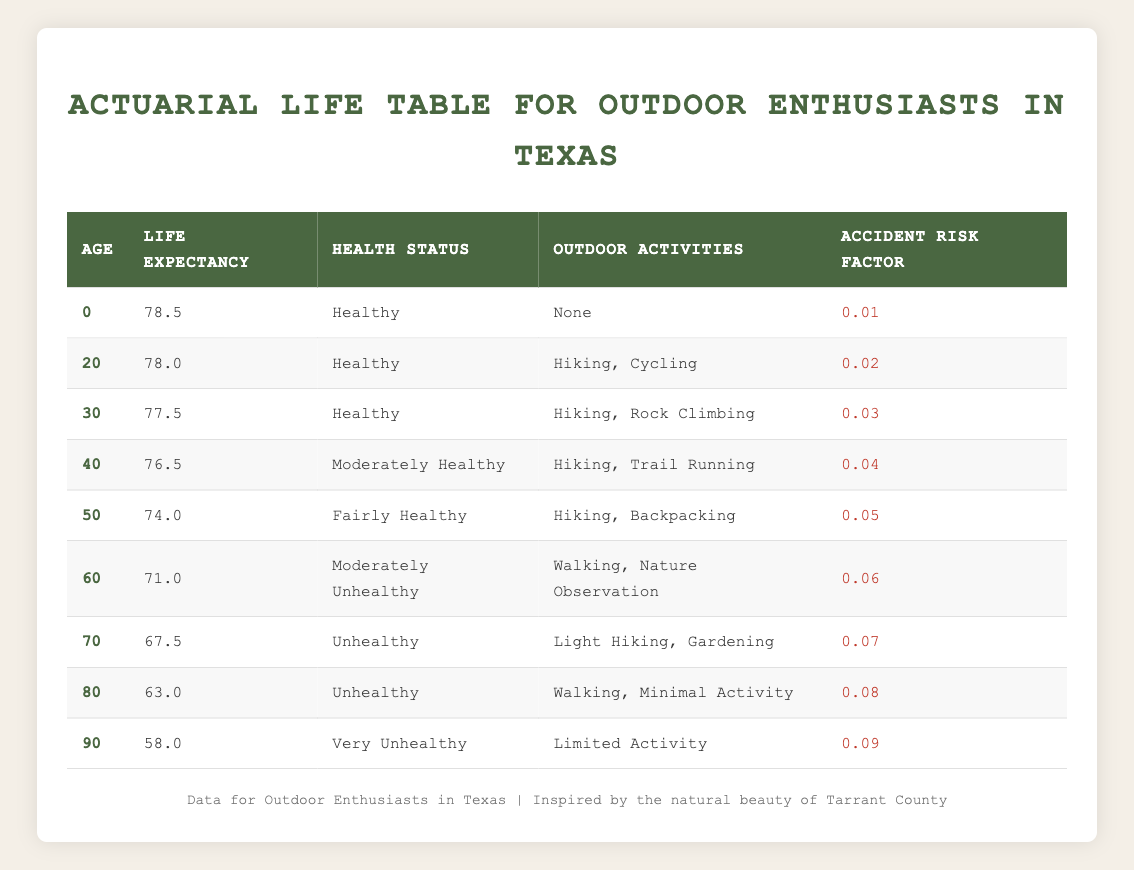What is the life expectancy of outdoor enthusiasts at age 50? From the table, the life expectancy at age 50 is 74.0. This value is directly retrieved from the row corresponding to age 50.
Answer: 74.0 What is the health status of outdoor enthusiasts who are 70 years old? Referring to the table, the health status for individuals at age 70 is listed as "Unhealthy." This is a direct retrieval of the relevant data point.
Answer: Unhealthy At what age does the life expectancy drop below 70 years? By inspecting the table, we see that life expectancy drops below 70 years at age 60 (71.0) and continues to decrease thereafter. Thus, the age at which life expectancy first drops below 70 is 70.
Answer: 70 What is the average life expectancy of outdoor enthusiasts aged 60 and older? To find the average, we take the life expectations at ages 60 (71.0), 70 (67.5), 80 (63.0), and 90 (58.0). Adding these gives 71.0 + 67.5 + 63.0 + 58.0 = 259.0. There are 4 data points, so the average is 259.0 / 4 = 64.75.
Answer: 64.75 Is the accident risk factor higher for those aged 40 than for those aged 30? From the table, the accident risk factor for age 40 is 0.04 while for age 30 it is 0.03. Since 0.04 is greater than 0.03, we conclude it's true that the risk is higher for the 40-year-olds.
Answer: Yes How much does life expectancy decline from age 20 to age 50? Looking at the life expectancy values, age 20 has 78.0 and age 50 has 74.0. The decline is calculated as 78.0 - 74.0 = 4.0 years.
Answer: 4.0 What is the highest accident risk factor in the table, and at what age does it occur? The accident risk factors are as follows: 0.01 at age 0, 0.02 at age 20, 0.03 at age 30, 0.04 at age 40, 0.05 at age 50, 0.06 at age 60, 0.07 at age 70, 0.08 at age 80, and 0.09 at age 90. The highest is 0.09 at age 90.
Answer: 0.09 at age 90 Which age group has a health status of "Moderately Unhealthy"? Referring to the table, the age group with a health status of "Moderately Unhealthy" is age 60. This is a direct retrieval of the health status data for that age.
Answer: 60 What outdoor activities do healthy outdoor enthusiasts aged 30 engage in? The table indicates that healthy outdoor enthusiasts aged 30 engage in "Hiking, Rock Climbing." This information directly correlates with the data point for age 30.
Answer: Hiking, Rock Climbing 